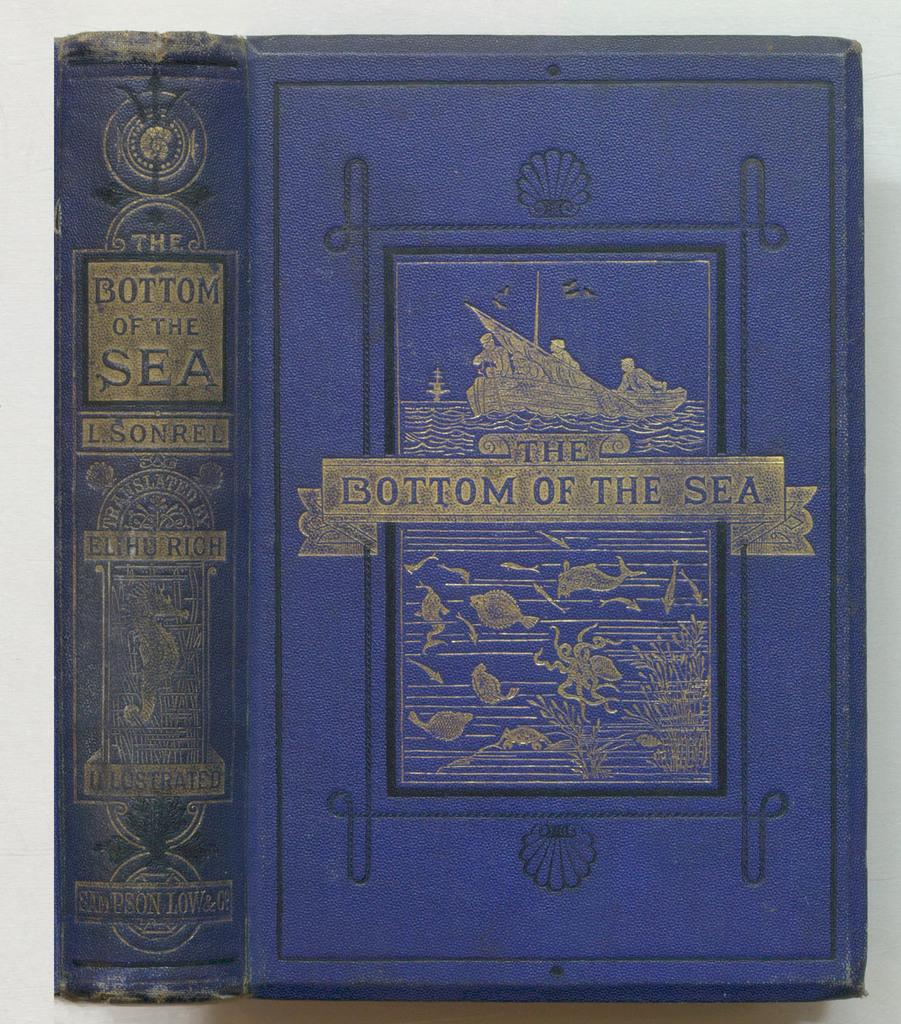<image>
Offer a succinct explanation of the picture presented. The Bottom of the Sea book that has a blue color 